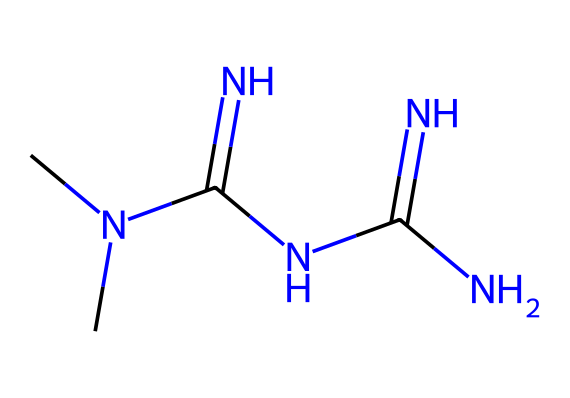What is the total number of nitrogen atoms in metformin? The SMILES representation shows "CN(C)C(=N)NC(=N)N." By analyzing the structure, we can count the nitrogen (N) atoms. There are five N atoms in total.
Answer: five What is the main functional group present in metformin? In the given SMILES, the "C(=N)" indicates the presence of imine groups. These C=N functionalities suggest the molecule contains amine functionality as well.
Answer: amine How many carbon atoms are in the chemical structure of metformin? The SMILES indicates "C" for carbon, and by analyzing it, there are 2 carbon atoms in total present in the structure of metformin.
Answer: two What type of chemical structure does metformin belong to? Metformin contains multiple nitrogen and carbon atoms forming a complex structure, classifying it as a biguanide derivative; hence its class of medicinal structure is categorized as biguanide.
Answer: biguanide How many total atoms are in the chemical composition of metformin? To determine the total number of atoms, sum up the number of carbon (C), nitrogen (N), and hydrogen (H). From the SMILES: 2C (2) + 5N (5) + 11H (11) gives a total of 18 atoms.
Answer: eighteen 